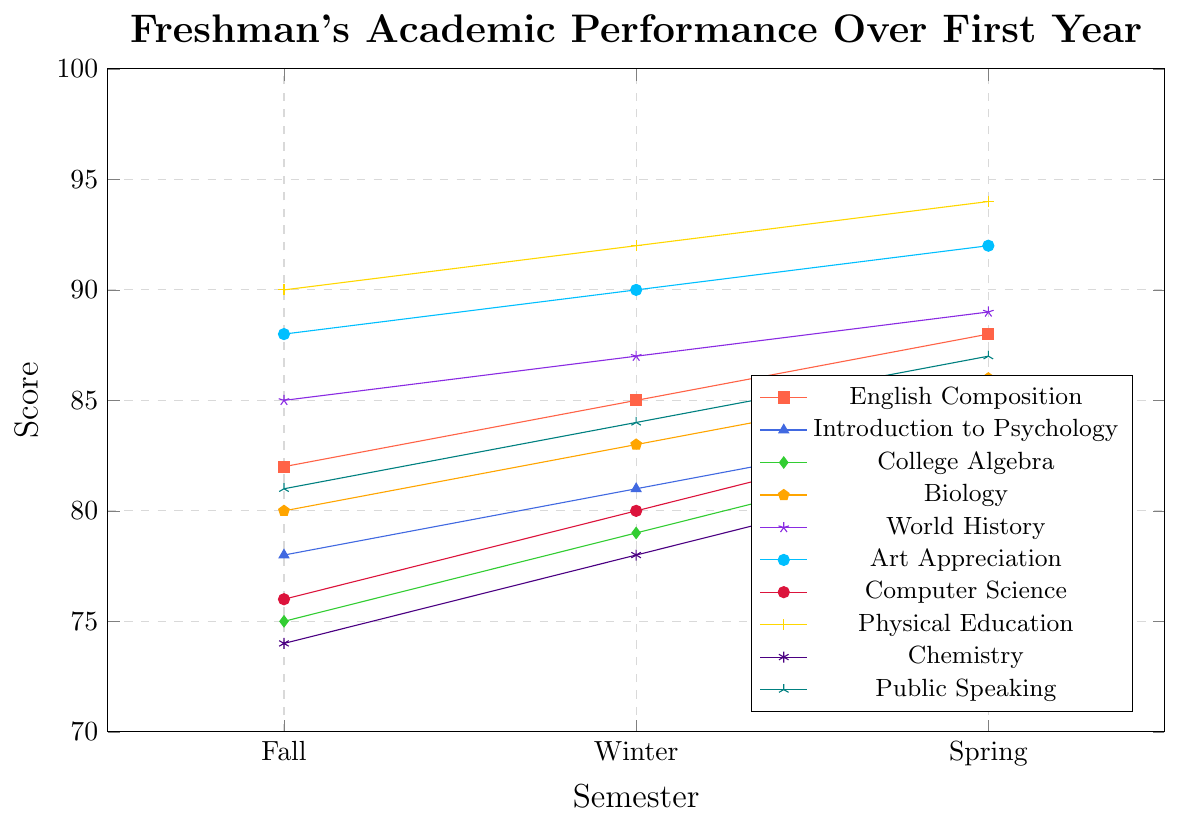What subject saw the largest rise in scores from Fall to Spring? To find this, look at the differences in scores for each subject from Fall to Spring. For example, for English Composition, the rise is 88 - 82 = 6. Repeat this for all subjects and find the maximum rise.
Answer: Physical Education (4-point rise) Which subject had the highest score in the Fall semester? Compare the scores for each subject in the Fall semester. Notice the highest score.
Answer: Physical Education (90) Which subject showed a consistent improvement every semester, ending with a score of 88? Look for subjects whose scores increased each semester. Then, see if any ended with a score of 88.
Answer: English Composition On average, by how much did the score increase from the Fall to the Winter semester across all subjects? Calculate the score increase for each subject from Fall to Winter: 85-82, 81-78, etc., and find the average of these increases.
Answer: 3.1 Which subject saw the smallest improvement from Winter to Spring? Subtract Winter scores from Spring scores for each subject and find the smallest positive difference.
Answer: Introduction to Psychology (3) Between College Algebra and Chemistry, which subject had a higher score in the Winter semester? Compare the scores of College Algebra (79) and Chemistry (78) in the Winter semester.
Answer: College Algebra (79) What is the color associated with Computer Science in the plot? Look at the legend for the color matching Computer Science.
Answer: Blue Calculate the average score across all subjects in the Spring semester. Sum the Spring scores and divide by the number of subjects: (88 + 84 + 83 + 86 + 89 + 92 + 84 + 94 + 82 + 87) / 10.
Answer: 86.9 Which subject has the steepest upward slope in its scores over the year? Evaluate the differences between scores for each semester across all subjects and identify the one with the maximum slope, calculated as Spring score - Fall score.
Answer: Physical Education 